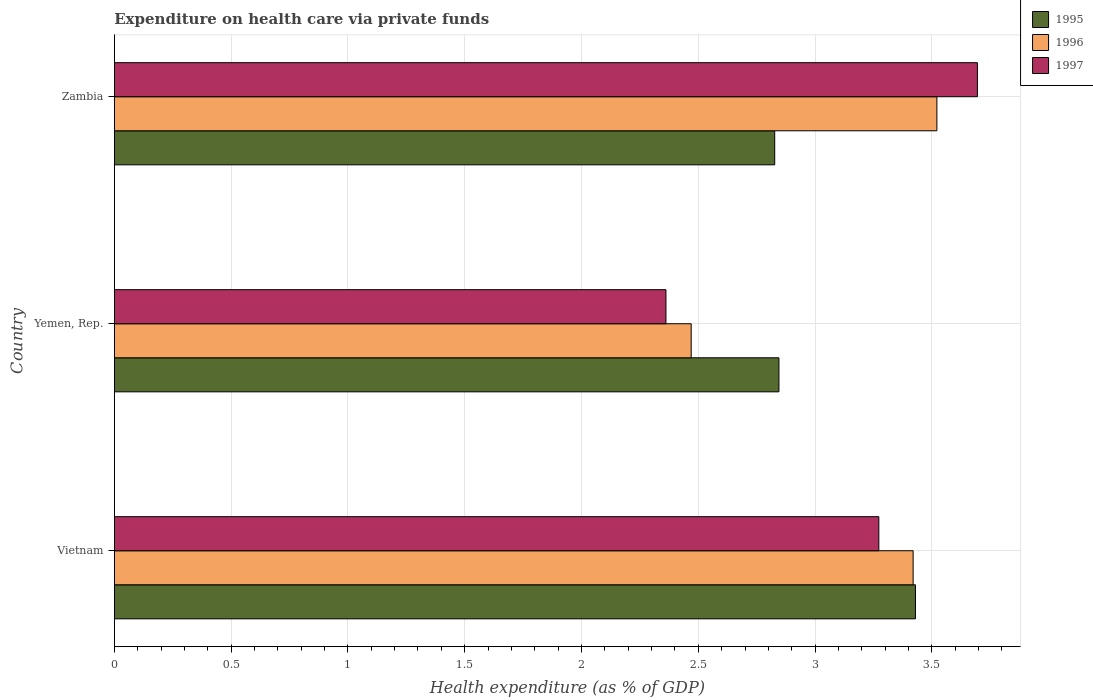How many different coloured bars are there?
Your answer should be very brief. 3. How many bars are there on the 2nd tick from the top?
Your response must be concise. 3. How many bars are there on the 1st tick from the bottom?
Your answer should be very brief. 3. What is the label of the 1st group of bars from the top?
Provide a succinct answer. Zambia. In how many cases, is the number of bars for a given country not equal to the number of legend labels?
Offer a terse response. 0. What is the expenditure made on health care in 1996 in Zambia?
Provide a short and direct response. 3.52. Across all countries, what is the maximum expenditure made on health care in 1996?
Provide a short and direct response. 3.52. Across all countries, what is the minimum expenditure made on health care in 1995?
Provide a short and direct response. 2.83. In which country was the expenditure made on health care in 1996 maximum?
Your response must be concise. Zambia. In which country was the expenditure made on health care in 1997 minimum?
Ensure brevity in your answer.  Yemen, Rep. What is the total expenditure made on health care in 1997 in the graph?
Keep it short and to the point. 9.33. What is the difference between the expenditure made on health care in 1997 in Vietnam and that in Yemen, Rep.?
Your answer should be compact. 0.91. What is the difference between the expenditure made on health care in 1995 in Yemen, Rep. and the expenditure made on health care in 1997 in Zambia?
Provide a short and direct response. -0.85. What is the average expenditure made on health care in 1996 per country?
Give a very brief answer. 3.14. What is the difference between the expenditure made on health care in 1996 and expenditure made on health care in 1995 in Vietnam?
Ensure brevity in your answer.  -0.01. What is the ratio of the expenditure made on health care in 1997 in Vietnam to that in Zambia?
Offer a terse response. 0.89. Is the difference between the expenditure made on health care in 1996 in Vietnam and Yemen, Rep. greater than the difference between the expenditure made on health care in 1995 in Vietnam and Yemen, Rep.?
Provide a short and direct response. Yes. What is the difference between the highest and the second highest expenditure made on health care in 1996?
Offer a terse response. 0.1. What is the difference between the highest and the lowest expenditure made on health care in 1996?
Make the answer very short. 1.05. What does the 1st bar from the top in Zambia represents?
Make the answer very short. 1997. Is it the case that in every country, the sum of the expenditure made on health care in 1997 and expenditure made on health care in 1995 is greater than the expenditure made on health care in 1996?
Make the answer very short. Yes. How many bars are there?
Ensure brevity in your answer.  9. Are all the bars in the graph horizontal?
Offer a very short reply. Yes. What is the difference between two consecutive major ticks on the X-axis?
Provide a short and direct response. 0.5. Does the graph contain any zero values?
Keep it short and to the point. No. How are the legend labels stacked?
Make the answer very short. Vertical. What is the title of the graph?
Provide a succinct answer. Expenditure on health care via private funds. Does "1999" appear as one of the legend labels in the graph?
Provide a short and direct response. No. What is the label or title of the X-axis?
Offer a very short reply. Health expenditure (as % of GDP). What is the Health expenditure (as % of GDP) of 1995 in Vietnam?
Keep it short and to the point. 3.43. What is the Health expenditure (as % of GDP) in 1996 in Vietnam?
Your response must be concise. 3.42. What is the Health expenditure (as % of GDP) in 1997 in Vietnam?
Ensure brevity in your answer.  3.27. What is the Health expenditure (as % of GDP) of 1995 in Yemen, Rep.?
Make the answer very short. 2.85. What is the Health expenditure (as % of GDP) of 1996 in Yemen, Rep.?
Offer a very short reply. 2.47. What is the Health expenditure (as % of GDP) in 1997 in Yemen, Rep.?
Keep it short and to the point. 2.36. What is the Health expenditure (as % of GDP) of 1995 in Zambia?
Give a very brief answer. 2.83. What is the Health expenditure (as % of GDP) in 1996 in Zambia?
Your answer should be compact. 3.52. What is the Health expenditure (as % of GDP) in 1997 in Zambia?
Provide a succinct answer. 3.69. Across all countries, what is the maximum Health expenditure (as % of GDP) in 1995?
Provide a short and direct response. 3.43. Across all countries, what is the maximum Health expenditure (as % of GDP) in 1996?
Provide a succinct answer. 3.52. Across all countries, what is the maximum Health expenditure (as % of GDP) in 1997?
Provide a short and direct response. 3.69. Across all countries, what is the minimum Health expenditure (as % of GDP) of 1995?
Offer a very short reply. 2.83. Across all countries, what is the minimum Health expenditure (as % of GDP) in 1996?
Ensure brevity in your answer.  2.47. Across all countries, what is the minimum Health expenditure (as % of GDP) in 1997?
Give a very brief answer. 2.36. What is the total Health expenditure (as % of GDP) of 1995 in the graph?
Make the answer very short. 9.1. What is the total Health expenditure (as % of GDP) of 1996 in the graph?
Your response must be concise. 9.41. What is the total Health expenditure (as % of GDP) in 1997 in the graph?
Make the answer very short. 9.33. What is the difference between the Health expenditure (as % of GDP) in 1995 in Vietnam and that in Yemen, Rep.?
Offer a very short reply. 0.58. What is the difference between the Health expenditure (as % of GDP) of 1996 in Vietnam and that in Yemen, Rep.?
Provide a short and direct response. 0.95. What is the difference between the Health expenditure (as % of GDP) in 1997 in Vietnam and that in Yemen, Rep.?
Provide a short and direct response. 0.91. What is the difference between the Health expenditure (as % of GDP) of 1995 in Vietnam and that in Zambia?
Offer a very short reply. 0.6. What is the difference between the Health expenditure (as % of GDP) of 1996 in Vietnam and that in Zambia?
Offer a very short reply. -0.1. What is the difference between the Health expenditure (as % of GDP) of 1997 in Vietnam and that in Zambia?
Keep it short and to the point. -0.42. What is the difference between the Health expenditure (as % of GDP) of 1995 in Yemen, Rep. and that in Zambia?
Ensure brevity in your answer.  0.02. What is the difference between the Health expenditure (as % of GDP) in 1996 in Yemen, Rep. and that in Zambia?
Your answer should be compact. -1.05. What is the difference between the Health expenditure (as % of GDP) in 1997 in Yemen, Rep. and that in Zambia?
Your answer should be compact. -1.33. What is the difference between the Health expenditure (as % of GDP) of 1995 in Vietnam and the Health expenditure (as % of GDP) of 1996 in Yemen, Rep.?
Ensure brevity in your answer.  0.96. What is the difference between the Health expenditure (as % of GDP) of 1995 in Vietnam and the Health expenditure (as % of GDP) of 1997 in Yemen, Rep.?
Ensure brevity in your answer.  1.07. What is the difference between the Health expenditure (as % of GDP) of 1996 in Vietnam and the Health expenditure (as % of GDP) of 1997 in Yemen, Rep.?
Offer a terse response. 1.06. What is the difference between the Health expenditure (as % of GDP) in 1995 in Vietnam and the Health expenditure (as % of GDP) in 1996 in Zambia?
Give a very brief answer. -0.09. What is the difference between the Health expenditure (as % of GDP) of 1995 in Vietnam and the Health expenditure (as % of GDP) of 1997 in Zambia?
Make the answer very short. -0.27. What is the difference between the Health expenditure (as % of GDP) in 1996 in Vietnam and the Health expenditure (as % of GDP) in 1997 in Zambia?
Offer a very short reply. -0.28. What is the difference between the Health expenditure (as % of GDP) in 1995 in Yemen, Rep. and the Health expenditure (as % of GDP) in 1996 in Zambia?
Make the answer very short. -0.68. What is the difference between the Health expenditure (as % of GDP) of 1995 in Yemen, Rep. and the Health expenditure (as % of GDP) of 1997 in Zambia?
Provide a short and direct response. -0.85. What is the difference between the Health expenditure (as % of GDP) of 1996 in Yemen, Rep. and the Health expenditure (as % of GDP) of 1997 in Zambia?
Provide a succinct answer. -1.23. What is the average Health expenditure (as % of GDP) in 1995 per country?
Ensure brevity in your answer.  3.03. What is the average Health expenditure (as % of GDP) in 1996 per country?
Give a very brief answer. 3.14. What is the average Health expenditure (as % of GDP) in 1997 per country?
Keep it short and to the point. 3.11. What is the difference between the Health expenditure (as % of GDP) of 1995 and Health expenditure (as % of GDP) of 1997 in Vietnam?
Make the answer very short. 0.16. What is the difference between the Health expenditure (as % of GDP) in 1996 and Health expenditure (as % of GDP) in 1997 in Vietnam?
Your answer should be compact. 0.15. What is the difference between the Health expenditure (as % of GDP) of 1995 and Health expenditure (as % of GDP) of 1996 in Yemen, Rep.?
Provide a succinct answer. 0.38. What is the difference between the Health expenditure (as % of GDP) in 1995 and Health expenditure (as % of GDP) in 1997 in Yemen, Rep.?
Your answer should be very brief. 0.48. What is the difference between the Health expenditure (as % of GDP) of 1996 and Health expenditure (as % of GDP) of 1997 in Yemen, Rep.?
Keep it short and to the point. 0.11. What is the difference between the Health expenditure (as % of GDP) in 1995 and Health expenditure (as % of GDP) in 1996 in Zambia?
Your response must be concise. -0.69. What is the difference between the Health expenditure (as % of GDP) of 1995 and Health expenditure (as % of GDP) of 1997 in Zambia?
Provide a succinct answer. -0.87. What is the difference between the Health expenditure (as % of GDP) of 1996 and Health expenditure (as % of GDP) of 1997 in Zambia?
Provide a short and direct response. -0.17. What is the ratio of the Health expenditure (as % of GDP) in 1995 in Vietnam to that in Yemen, Rep.?
Provide a succinct answer. 1.21. What is the ratio of the Health expenditure (as % of GDP) in 1996 in Vietnam to that in Yemen, Rep.?
Provide a succinct answer. 1.38. What is the ratio of the Health expenditure (as % of GDP) of 1997 in Vietnam to that in Yemen, Rep.?
Your answer should be very brief. 1.39. What is the ratio of the Health expenditure (as % of GDP) in 1995 in Vietnam to that in Zambia?
Your response must be concise. 1.21. What is the ratio of the Health expenditure (as % of GDP) in 1996 in Vietnam to that in Zambia?
Provide a short and direct response. 0.97. What is the ratio of the Health expenditure (as % of GDP) in 1997 in Vietnam to that in Zambia?
Offer a terse response. 0.89. What is the ratio of the Health expenditure (as % of GDP) in 1995 in Yemen, Rep. to that in Zambia?
Your answer should be very brief. 1.01. What is the ratio of the Health expenditure (as % of GDP) in 1996 in Yemen, Rep. to that in Zambia?
Your answer should be very brief. 0.7. What is the ratio of the Health expenditure (as % of GDP) of 1997 in Yemen, Rep. to that in Zambia?
Your answer should be very brief. 0.64. What is the difference between the highest and the second highest Health expenditure (as % of GDP) of 1995?
Give a very brief answer. 0.58. What is the difference between the highest and the second highest Health expenditure (as % of GDP) of 1996?
Provide a short and direct response. 0.1. What is the difference between the highest and the second highest Health expenditure (as % of GDP) of 1997?
Your answer should be compact. 0.42. What is the difference between the highest and the lowest Health expenditure (as % of GDP) of 1995?
Your answer should be very brief. 0.6. What is the difference between the highest and the lowest Health expenditure (as % of GDP) of 1996?
Ensure brevity in your answer.  1.05. 